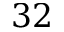Convert formula to latex. <formula><loc_0><loc_0><loc_500><loc_500>3 2</formula> 